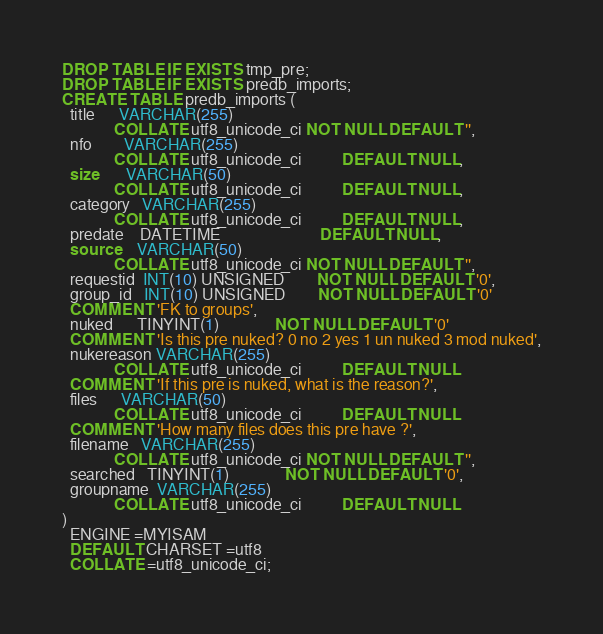<code> <loc_0><loc_0><loc_500><loc_500><_SQL_>DROP TABLE IF EXISTS tmp_pre;
DROP TABLE IF EXISTS predb_imports;
CREATE TABLE predb_imports (
  title      VARCHAR(255)
             COLLATE utf8_unicode_ci NOT NULL DEFAULT '',
  nfo        VARCHAR(255)
             COLLATE utf8_unicode_ci          DEFAULT NULL,
  size       VARCHAR(50)
             COLLATE utf8_unicode_ci          DEFAULT NULL,
  category   VARCHAR(255)
             COLLATE utf8_unicode_ci          DEFAULT NULL,
  predate    DATETIME                         DEFAULT NULL,
  source     VARCHAR(50)
             COLLATE utf8_unicode_ci NOT NULL DEFAULT '',
  requestid  INT(10) UNSIGNED        NOT NULL DEFAULT '0',
  group_id   INT(10) UNSIGNED        NOT NULL DEFAULT '0'
  COMMENT 'FK to groups',
  nuked      TINYINT(1)              NOT NULL DEFAULT '0'
  COMMENT 'Is this pre nuked? 0 no 2 yes 1 un nuked 3 mod nuked',
  nukereason VARCHAR(255)
             COLLATE utf8_unicode_ci          DEFAULT NULL
  COMMENT 'If this pre is nuked, what is the reason?',
  files      VARCHAR(50)
             COLLATE utf8_unicode_ci          DEFAULT NULL
  COMMENT 'How many files does this pre have ?',
  filename   VARCHAR(255)
             COLLATE utf8_unicode_ci NOT NULL DEFAULT '',
  searched   TINYINT(1)              NOT NULL DEFAULT '0',
  groupname  VARCHAR(255)
             COLLATE utf8_unicode_ci          DEFAULT NULL
)
  ENGINE =MYISAM
  DEFAULT CHARSET =utf8
  COLLATE =utf8_unicode_ci;
</code> 